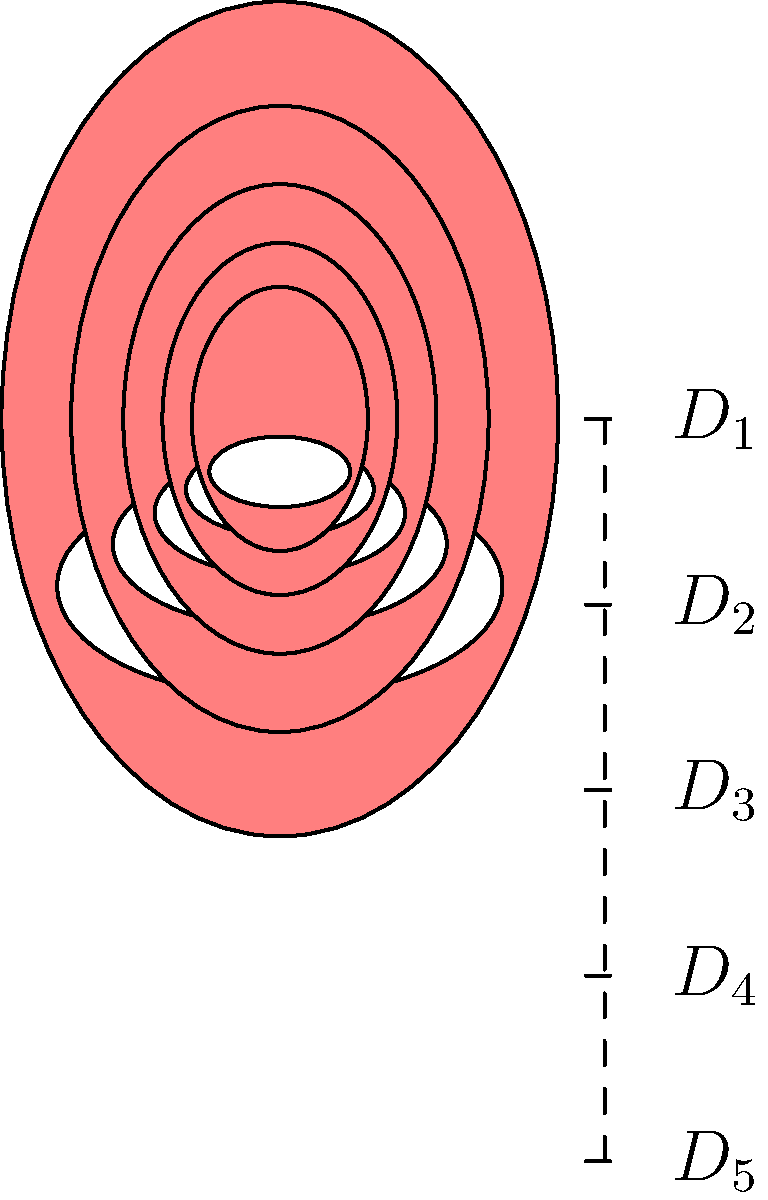In a set of nested matryoshka dolls, each doll is scaled down by a factor of 0.75 from the previous one. If the height of the largest doll ($D_1$) is 15 cm, what is the height of the smallest visible doll ($D_5$) in the set? Let's approach this step-by-step:

1) We know that each doll is scaled down by a factor of 0.75 from the previous one.

2) Let's denote the height of each doll as $h_1, h_2, h_3, h_4, h_5$, where $h_1 = 15$ cm (the height of the largest doll).

3) We can express the height of each subsequent doll as:
   $h_2 = 0.75 \cdot h_1$
   $h_3 = 0.75 \cdot h_2 = 0.75^2 \cdot h_1$
   $h_4 = 0.75 \cdot h_3 = 0.75^3 \cdot h_1$
   $h_5 = 0.75 \cdot h_4 = 0.75^4 \cdot h_1$

4) Therefore, the height of the smallest visible doll ($D_5$) can be calculated as:
   $h_5 = 0.75^4 \cdot 15$

5) Let's calculate this:
   $h_5 = 0.75^4 \cdot 15$
   $= 0.3164 \cdot 15$
   $= 4.746$ cm

6) Rounding to two decimal places, we get 4.75 cm.
Answer: 4.75 cm 